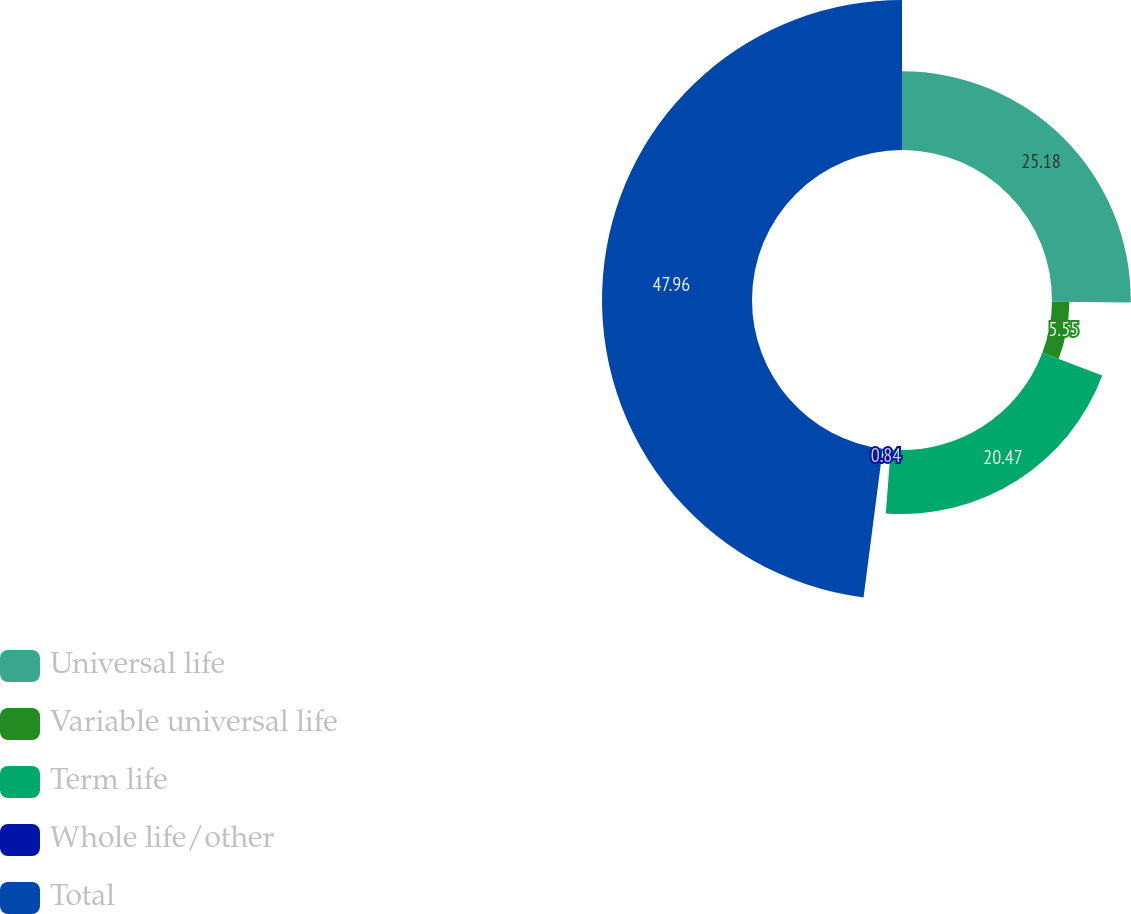Convert chart to OTSL. <chart><loc_0><loc_0><loc_500><loc_500><pie_chart><fcel>Universal life<fcel>Variable universal life<fcel>Term life<fcel>Whole life/other<fcel>Total<nl><fcel>25.18%<fcel>5.55%<fcel>20.47%<fcel>0.84%<fcel>47.95%<nl></chart> 